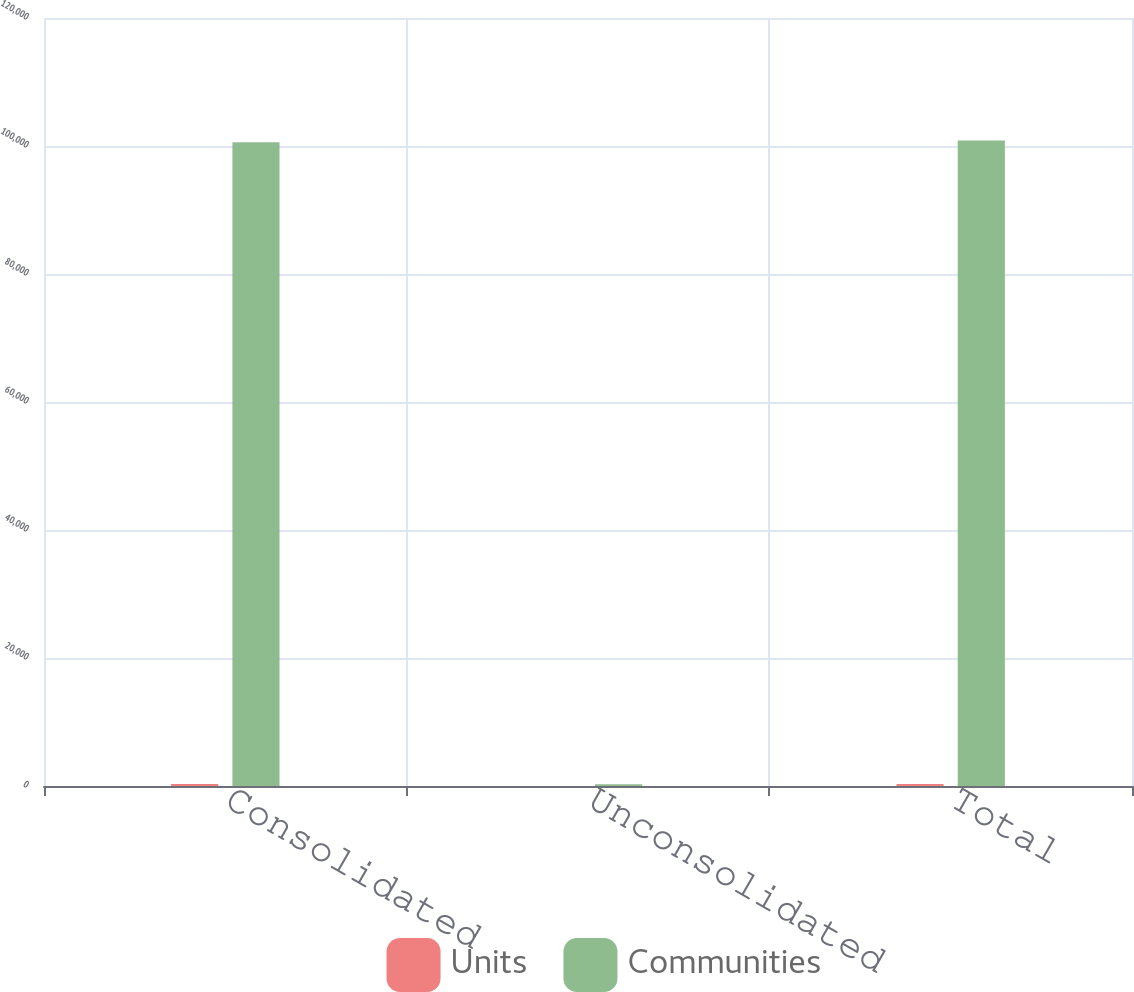Convert chart. <chart><loc_0><loc_0><loc_500><loc_500><stacked_bar_chart><ecel><fcel>Consolidated<fcel>Unconsolidated<fcel>Total<nl><fcel>Units<fcel>303<fcel>1<fcel>304<nl><fcel>Communities<fcel>100595<fcel>269<fcel>100864<nl></chart> 